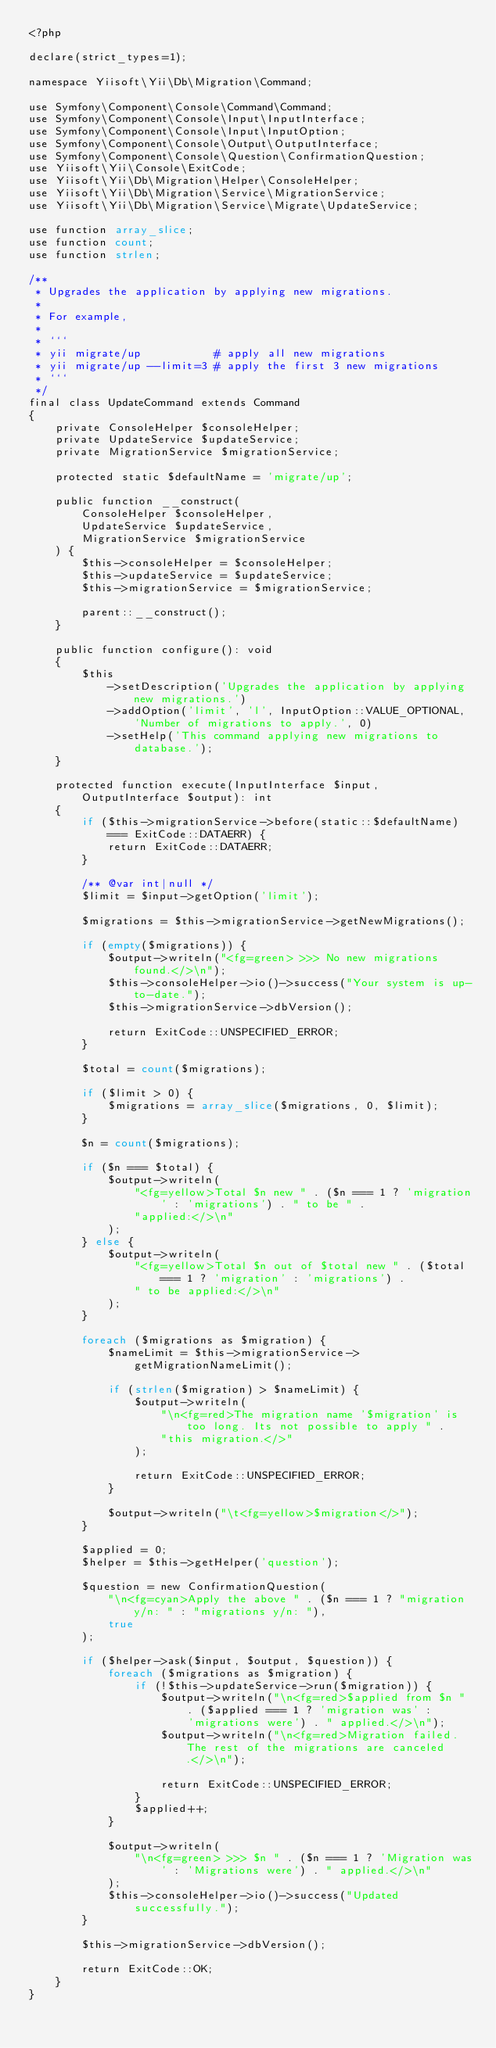<code> <loc_0><loc_0><loc_500><loc_500><_PHP_><?php

declare(strict_types=1);

namespace Yiisoft\Yii\Db\Migration\Command;

use Symfony\Component\Console\Command\Command;
use Symfony\Component\Console\Input\InputInterface;
use Symfony\Component\Console\Input\InputOption;
use Symfony\Component\Console\Output\OutputInterface;
use Symfony\Component\Console\Question\ConfirmationQuestion;
use Yiisoft\Yii\Console\ExitCode;
use Yiisoft\Yii\Db\Migration\Helper\ConsoleHelper;
use Yiisoft\Yii\Db\Migration\Service\MigrationService;
use Yiisoft\Yii\Db\Migration\Service\Migrate\UpdateService;

use function array_slice;
use function count;
use function strlen;

/**
 * Upgrades the application by applying new migrations.
 *
 * For example,
 *
 * ```
 * yii migrate/up           # apply all new migrations
 * yii migrate/up --limit=3 # apply the first 3 new migrations
 * ```
 */
final class UpdateCommand extends Command
{
    private ConsoleHelper $consoleHelper;
    private UpdateService $updateService;
    private MigrationService $migrationService;

    protected static $defaultName = 'migrate/up';

    public function __construct(
        ConsoleHelper $consoleHelper,
        UpdateService $updateService,
        MigrationService $migrationService
    ) {
        $this->consoleHelper = $consoleHelper;
        $this->updateService = $updateService;
        $this->migrationService = $migrationService;

        parent::__construct();
    }

    public function configure(): void
    {
        $this
            ->setDescription('Upgrades the application by applying new migrations.')
            ->addOption('limit', 'l', InputOption::VALUE_OPTIONAL, 'Number of migrations to apply.', 0)
            ->setHelp('This command applying new migrations to database.');
    }

    protected function execute(InputInterface $input, OutputInterface $output): int
    {
        if ($this->migrationService->before(static::$defaultName) === ExitCode::DATAERR) {
            return ExitCode::DATAERR;
        }

        /** @var int|null */
        $limit = $input->getOption('limit');

        $migrations = $this->migrationService->getNewMigrations();

        if (empty($migrations)) {
            $output->writeln("<fg=green> >>> No new migrations found.</>\n");
            $this->consoleHelper->io()->success("Your system is up-to-date.");
            $this->migrationService->dbVersion();

            return ExitCode::UNSPECIFIED_ERROR;
        }

        $total = count($migrations);

        if ($limit > 0) {
            $migrations = array_slice($migrations, 0, $limit);
        }

        $n = count($migrations);

        if ($n === $total) {
            $output->writeln(
                "<fg=yellow>Total $n new " . ($n === 1 ? 'migration' : 'migrations') . " to be " .
                "applied:</>\n"
            );
        } else {
            $output->writeln(
                "<fg=yellow>Total $n out of $total new " . ($total === 1 ? 'migration' : 'migrations') .
                " to be applied:</>\n"
            );
        }

        foreach ($migrations as $migration) {
            $nameLimit = $this->migrationService->getMigrationNameLimit();

            if (strlen($migration) > $nameLimit) {
                $output->writeln(
                    "\n<fg=red>The migration name '$migration' is too long. Its not possible to apply " .
                    "this migration.</>"
                );

                return ExitCode::UNSPECIFIED_ERROR;
            }

            $output->writeln("\t<fg=yellow>$migration</>");
        }

        $applied = 0;
        $helper = $this->getHelper('question');

        $question = new ConfirmationQuestion(
            "\n<fg=cyan>Apply the above " . ($n === 1 ? "migration y/n: " : "migrations y/n: "),
            true
        );

        if ($helper->ask($input, $output, $question)) {
            foreach ($migrations as $migration) {
                if (!$this->updateService->run($migration)) {
                    $output->writeln("\n<fg=red>$applied from $n " . ($applied === 1 ? 'migration was' :
                        'migrations were') . " applied.</>\n");
                    $output->writeln("\n<fg=red>Migration failed. The rest of the migrations are canceled.</>\n");

                    return ExitCode::UNSPECIFIED_ERROR;
                }
                $applied++;
            }

            $output->writeln(
                "\n<fg=green> >>> $n " . ($n === 1 ? 'Migration was' : 'Migrations were') . " applied.</>\n"
            );
            $this->consoleHelper->io()->success("Updated successfully.");
        }

        $this->migrationService->dbVersion();

        return ExitCode::OK;
    }
}
</code> 